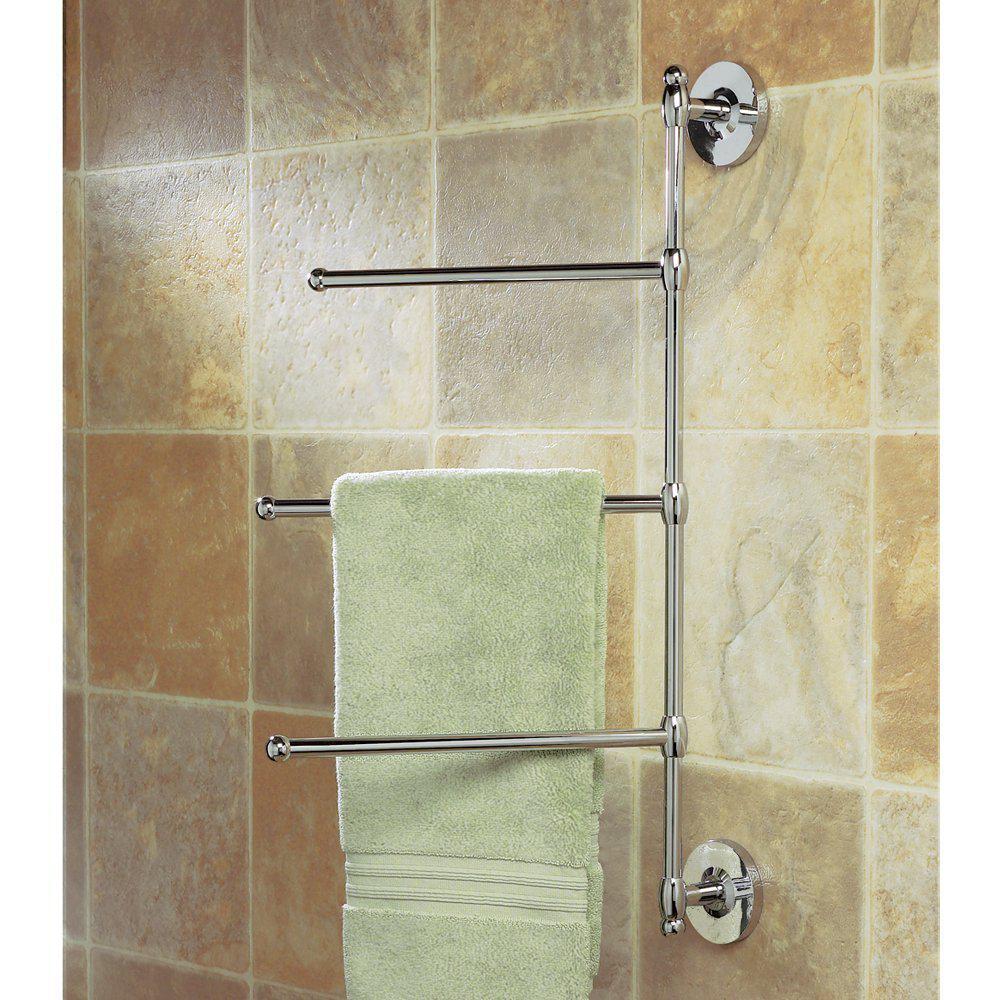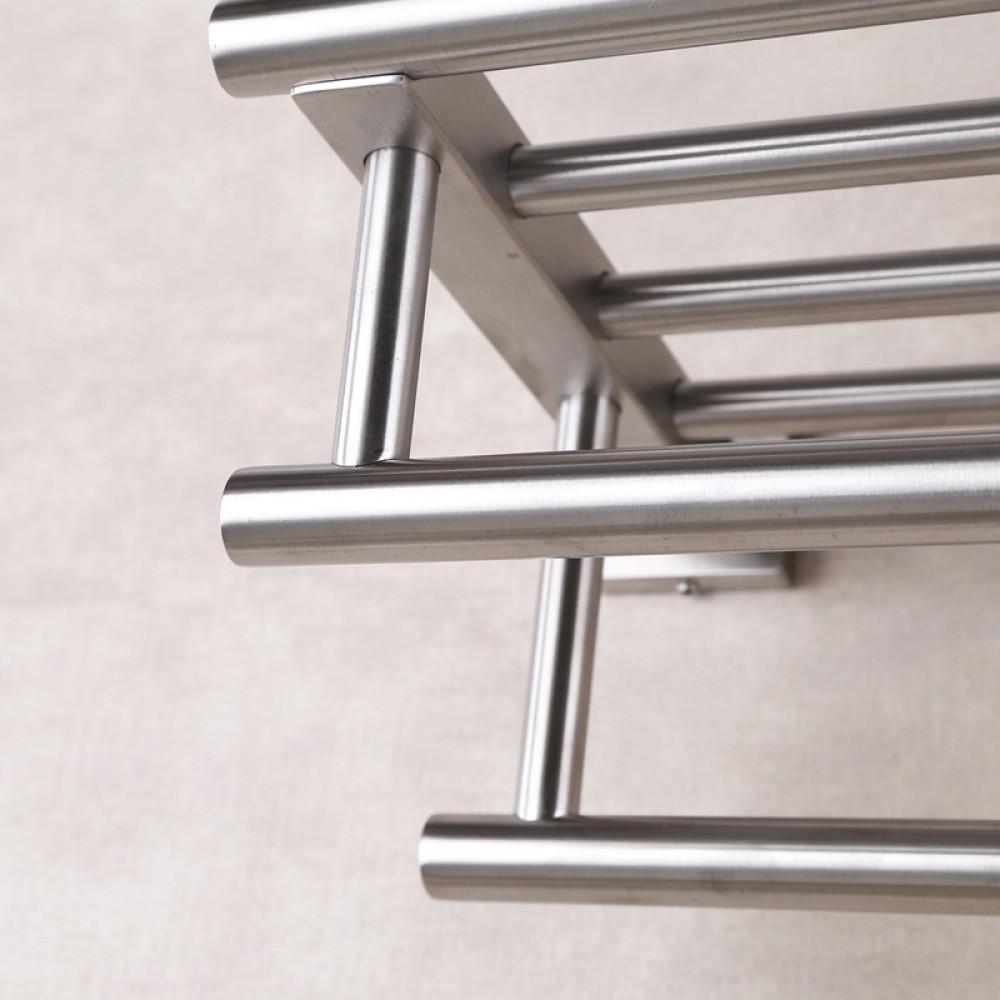The first image is the image on the left, the second image is the image on the right. For the images shown, is this caption "One of the racks has nothing on it." true? Answer yes or no. Yes. 